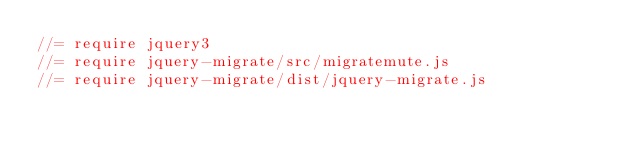<code> <loc_0><loc_0><loc_500><loc_500><_JavaScript_>//= require jquery3
//= require jquery-migrate/src/migratemute.js
//= require jquery-migrate/dist/jquery-migrate.js
</code> 